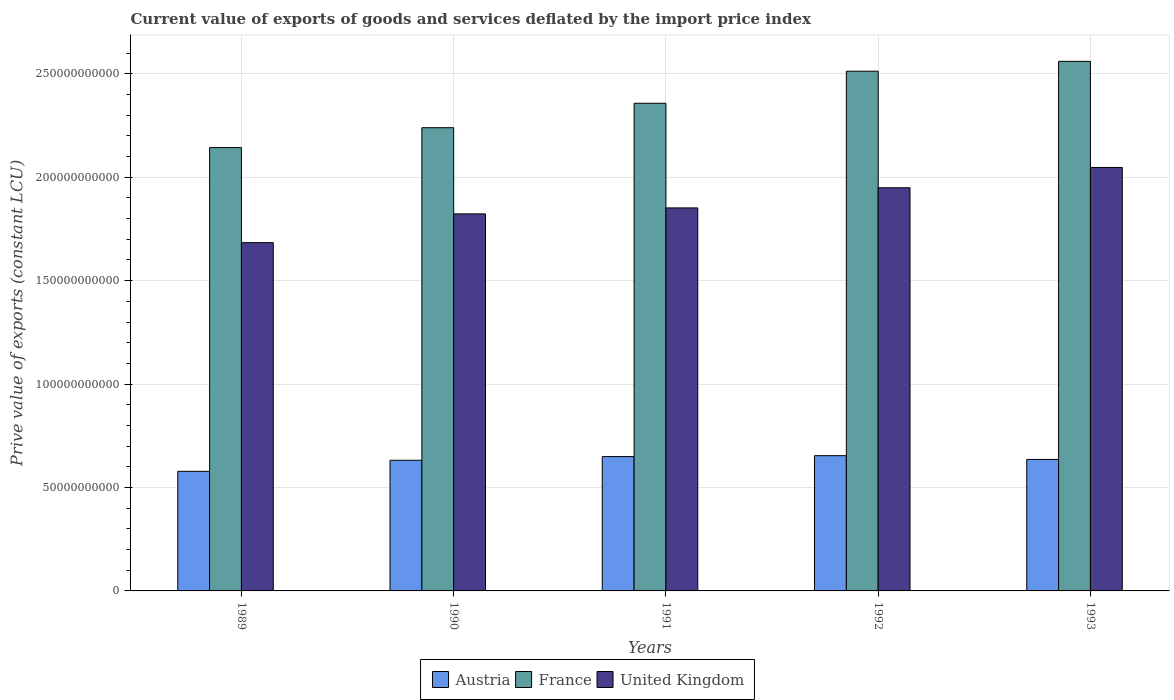How many different coloured bars are there?
Give a very brief answer. 3. How many groups of bars are there?
Your answer should be very brief. 5. Are the number of bars on each tick of the X-axis equal?
Make the answer very short. Yes. How many bars are there on the 2nd tick from the left?
Your response must be concise. 3. In how many cases, is the number of bars for a given year not equal to the number of legend labels?
Give a very brief answer. 0. What is the prive value of exports in France in 1991?
Make the answer very short. 2.36e+11. Across all years, what is the maximum prive value of exports in Austria?
Your answer should be very brief. 6.54e+1. Across all years, what is the minimum prive value of exports in Austria?
Give a very brief answer. 5.78e+1. In which year was the prive value of exports in United Kingdom maximum?
Make the answer very short. 1993. In which year was the prive value of exports in Austria minimum?
Your response must be concise. 1989. What is the total prive value of exports in France in the graph?
Your answer should be compact. 1.18e+12. What is the difference between the prive value of exports in Austria in 1990 and that in 1991?
Offer a terse response. -1.78e+09. What is the difference between the prive value of exports in Austria in 1992 and the prive value of exports in France in 1991?
Provide a short and direct response. -1.70e+11. What is the average prive value of exports in United Kingdom per year?
Ensure brevity in your answer.  1.87e+11. In the year 1991, what is the difference between the prive value of exports in Austria and prive value of exports in United Kingdom?
Make the answer very short. -1.20e+11. In how many years, is the prive value of exports in United Kingdom greater than 90000000000 LCU?
Make the answer very short. 5. What is the ratio of the prive value of exports in France in 1990 to that in 1991?
Your answer should be compact. 0.95. What is the difference between the highest and the second highest prive value of exports in Austria?
Provide a succinct answer. 4.35e+08. What is the difference between the highest and the lowest prive value of exports in United Kingdom?
Give a very brief answer. 3.63e+1. In how many years, is the prive value of exports in United Kingdom greater than the average prive value of exports in United Kingdom taken over all years?
Your response must be concise. 2. What does the 2nd bar from the right in 1993 represents?
Your answer should be compact. France. Are all the bars in the graph horizontal?
Offer a very short reply. No. Are the values on the major ticks of Y-axis written in scientific E-notation?
Your answer should be compact. No. Does the graph contain any zero values?
Give a very brief answer. No. Does the graph contain grids?
Provide a succinct answer. Yes. How many legend labels are there?
Keep it short and to the point. 3. How are the legend labels stacked?
Provide a succinct answer. Horizontal. What is the title of the graph?
Give a very brief answer. Current value of exports of goods and services deflated by the import price index. What is the label or title of the X-axis?
Your response must be concise. Years. What is the label or title of the Y-axis?
Give a very brief answer. Prive value of exports (constant LCU). What is the Prive value of exports (constant LCU) in Austria in 1989?
Your response must be concise. 5.78e+1. What is the Prive value of exports (constant LCU) in France in 1989?
Ensure brevity in your answer.  2.14e+11. What is the Prive value of exports (constant LCU) in United Kingdom in 1989?
Offer a terse response. 1.68e+11. What is the Prive value of exports (constant LCU) in Austria in 1990?
Offer a terse response. 6.32e+1. What is the Prive value of exports (constant LCU) of France in 1990?
Keep it short and to the point. 2.24e+11. What is the Prive value of exports (constant LCU) of United Kingdom in 1990?
Your response must be concise. 1.82e+11. What is the Prive value of exports (constant LCU) of Austria in 1991?
Your response must be concise. 6.49e+1. What is the Prive value of exports (constant LCU) in France in 1991?
Keep it short and to the point. 2.36e+11. What is the Prive value of exports (constant LCU) in United Kingdom in 1991?
Your answer should be very brief. 1.85e+11. What is the Prive value of exports (constant LCU) in Austria in 1992?
Your answer should be compact. 6.54e+1. What is the Prive value of exports (constant LCU) in France in 1992?
Ensure brevity in your answer.  2.51e+11. What is the Prive value of exports (constant LCU) of United Kingdom in 1992?
Provide a short and direct response. 1.95e+11. What is the Prive value of exports (constant LCU) in Austria in 1993?
Offer a very short reply. 6.36e+1. What is the Prive value of exports (constant LCU) in France in 1993?
Your answer should be very brief. 2.56e+11. What is the Prive value of exports (constant LCU) of United Kingdom in 1993?
Offer a very short reply. 2.05e+11. Across all years, what is the maximum Prive value of exports (constant LCU) of Austria?
Your response must be concise. 6.54e+1. Across all years, what is the maximum Prive value of exports (constant LCU) in France?
Give a very brief answer. 2.56e+11. Across all years, what is the maximum Prive value of exports (constant LCU) in United Kingdom?
Provide a succinct answer. 2.05e+11. Across all years, what is the minimum Prive value of exports (constant LCU) in Austria?
Your answer should be very brief. 5.78e+1. Across all years, what is the minimum Prive value of exports (constant LCU) in France?
Make the answer very short. 2.14e+11. Across all years, what is the minimum Prive value of exports (constant LCU) of United Kingdom?
Offer a terse response. 1.68e+11. What is the total Prive value of exports (constant LCU) in Austria in the graph?
Your answer should be compact. 3.15e+11. What is the total Prive value of exports (constant LCU) of France in the graph?
Ensure brevity in your answer.  1.18e+12. What is the total Prive value of exports (constant LCU) in United Kingdom in the graph?
Provide a succinct answer. 9.35e+11. What is the difference between the Prive value of exports (constant LCU) in Austria in 1989 and that in 1990?
Keep it short and to the point. -5.35e+09. What is the difference between the Prive value of exports (constant LCU) in France in 1989 and that in 1990?
Keep it short and to the point. -9.61e+09. What is the difference between the Prive value of exports (constant LCU) in United Kingdom in 1989 and that in 1990?
Offer a very short reply. -1.39e+1. What is the difference between the Prive value of exports (constant LCU) in Austria in 1989 and that in 1991?
Provide a succinct answer. -7.13e+09. What is the difference between the Prive value of exports (constant LCU) of France in 1989 and that in 1991?
Give a very brief answer. -2.14e+1. What is the difference between the Prive value of exports (constant LCU) in United Kingdom in 1989 and that in 1991?
Give a very brief answer. -1.68e+1. What is the difference between the Prive value of exports (constant LCU) of Austria in 1989 and that in 1992?
Your answer should be compact. -7.57e+09. What is the difference between the Prive value of exports (constant LCU) of France in 1989 and that in 1992?
Your answer should be very brief. -3.69e+1. What is the difference between the Prive value of exports (constant LCU) in United Kingdom in 1989 and that in 1992?
Your answer should be very brief. -2.65e+1. What is the difference between the Prive value of exports (constant LCU) in Austria in 1989 and that in 1993?
Give a very brief answer. -5.75e+09. What is the difference between the Prive value of exports (constant LCU) of France in 1989 and that in 1993?
Offer a terse response. -4.17e+1. What is the difference between the Prive value of exports (constant LCU) of United Kingdom in 1989 and that in 1993?
Make the answer very short. -3.63e+1. What is the difference between the Prive value of exports (constant LCU) in Austria in 1990 and that in 1991?
Offer a terse response. -1.78e+09. What is the difference between the Prive value of exports (constant LCU) in France in 1990 and that in 1991?
Give a very brief answer. -1.18e+1. What is the difference between the Prive value of exports (constant LCU) of United Kingdom in 1990 and that in 1991?
Give a very brief answer. -2.89e+09. What is the difference between the Prive value of exports (constant LCU) of Austria in 1990 and that in 1992?
Your answer should be very brief. -2.21e+09. What is the difference between the Prive value of exports (constant LCU) of France in 1990 and that in 1992?
Ensure brevity in your answer.  -2.73e+1. What is the difference between the Prive value of exports (constant LCU) of United Kingdom in 1990 and that in 1992?
Provide a succinct answer. -1.26e+1. What is the difference between the Prive value of exports (constant LCU) of Austria in 1990 and that in 1993?
Your response must be concise. -4.00e+08. What is the difference between the Prive value of exports (constant LCU) in France in 1990 and that in 1993?
Give a very brief answer. -3.21e+1. What is the difference between the Prive value of exports (constant LCU) of United Kingdom in 1990 and that in 1993?
Offer a very short reply. -2.24e+1. What is the difference between the Prive value of exports (constant LCU) in Austria in 1991 and that in 1992?
Your response must be concise. -4.35e+08. What is the difference between the Prive value of exports (constant LCU) in France in 1991 and that in 1992?
Ensure brevity in your answer.  -1.55e+1. What is the difference between the Prive value of exports (constant LCU) in United Kingdom in 1991 and that in 1992?
Provide a succinct answer. -9.74e+09. What is the difference between the Prive value of exports (constant LCU) in Austria in 1991 and that in 1993?
Your answer should be compact. 1.38e+09. What is the difference between the Prive value of exports (constant LCU) in France in 1991 and that in 1993?
Offer a very short reply. -2.03e+1. What is the difference between the Prive value of exports (constant LCU) in United Kingdom in 1991 and that in 1993?
Provide a short and direct response. -1.96e+1. What is the difference between the Prive value of exports (constant LCU) in Austria in 1992 and that in 1993?
Your answer should be very brief. 1.81e+09. What is the difference between the Prive value of exports (constant LCU) in France in 1992 and that in 1993?
Your response must be concise. -4.76e+09. What is the difference between the Prive value of exports (constant LCU) of United Kingdom in 1992 and that in 1993?
Provide a short and direct response. -9.81e+09. What is the difference between the Prive value of exports (constant LCU) of Austria in 1989 and the Prive value of exports (constant LCU) of France in 1990?
Give a very brief answer. -1.66e+11. What is the difference between the Prive value of exports (constant LCU) of Austria in 1989 and the Prive value of exports (constant LCU) of United Kingdom in 1990?
Make the answer very short. -1.24e+11. What is the difference between the Prive value of exports (constant LCU) in France in 1989 and the Prive value of exports (constant LCU) in United Kingdom in 1990?
Provide a short and direct response. 3.20e+1. What is the difference between the Prive value of exports (constant LCU) of Austria in 1989 and the Prive value of exports (constant LCU) of France in 1991?
Provide a succinct answer. -1.78e+11. What is the difference between the Prive value of exports (constant LCU) of Austria in 1989 and the Prive value of exports (constant LCU) of United Kingdom in 1991?
Your answer should be very brief. -1.27e+11. What is the difference between the Prive value of exports (constant LCU) of France in 1989 and the Prive value of exports (constant LCU) of United Kingdom in 1991?
Your response must be concise. 2.92e+1. What is the difference between the Prive value of exports (constant LCU) in Austria in 1989 and the Prive value of exports (constant LCU) in France in 1992?
Your answer should be compact. -1.93e+11. What is the difference between the Prive value of exports (constant LCU) in Austria in 1989 and the Prive value of exports (constant LCU) in United Kingdom in 1992?
Provide a succinct answer. -1.37e+11. What is the difference between the Prive value of exports (constant LCU) in France in 1989 and the Prive value of exports (constant LCU) in United Kingdom in 1992?
Offer a very short reply. 1.94e+1. What is the difference between the Prive value of exports (constant LCU) in Austria in 1989 and the Prive value of exports (constant LCU) in France in 1993?
Provide a succinct answer. -1.98e+11. What is the difference between the Prive value of exports (constant LCU) in Austria in 1989 and the Prive value of exports (constant LCU) in United Kingdom in 1993?
Make the answer very short. -1.47e+11. What is the difference between the Prive value of exports (constant LCU) in France in 1989 and the Prive value of exports (constant LCU) in United Kingdom in 1993?
Offer a terse response. 9.61e+09. What is the difference between the Prive value of exports (constant LCU) of Austria in 1990 and the Prive value of exports (constant LCU) of France in 1991?
Your answer should be very brief. -1.73e+11. What is the difference between the Prive value of exports (constant LCU) of Austria in 1990 and the Prive value of exports (constant LCU) of United Kingdom in 1991?
Keep it short and to the point. -1.22e+11. What is the difference between the Prive value of exports (constant LCU) of France in 1990 and the Prive value of exports (constant LCU) of United Kingdom in 1991?
Ensure brevity in your answer.  3.88e+1. What is the difference between the Prive value of exports (constant LCU) in Austria in 1990 and the Prive value of exports (constant LCU) in France in 1992?
Give a very brief answer. -1.88e+11. What is the difference between the Prive value of exports (constant LCU) of Austria in 1990 and the Prive value of exports (constant LCU) of United Kingdom in 1992?
Make the answer very short. -1.32e+11. What is the difference between the Prive value of exports (constant LCU) in France in 1990 and the Prive value of exports (constant LCU) in United Kingdom in 1992?
Ensure brevity in your answer.  2.90e+1. What is the difference between the Prive value of exports (constant LCU) of Austria in 1990 and the Prive value of exports (constant LCU) of France in 1993?
Your answer should be compact. -1.93e+11. What is the difference between the Prive value of exports (constant LCU) of Austria in 1990 and the Prive value of exports (constant LCU) of United Kingdom in 1993?
Keep it short and to the point. -1.42e+11. What is the difference between the Prive value of exports (constant LCU) in France in 1990 and the Prive value of exports (constant LCU) in United Kingdom in 1993?
Your response must be concise. 1.92e+1. What is the difference between the Prive value of exports (constant LCU) in Austria in 1991 and the Prive value of exports (constant LCU) in France in 1992?
Your response must be concise. -1.86e+11. What is the difference between the Prive value of exports (constant LCU) in Austria in 1991 and the Prive value of exports (constant LCU) in United Kingdom in 1992?
Offer a terse response. -1.30e+11. What is the difference between the Prive value of exports (constant LCU) in France in 1991 and the Prive value of exports (constant LCU) in United Kingdom in 1992?
Offer a very short reply. 4.09e+1. What is the difference between the Prive value of exports (constant LCU) of Austria in 1991 and the Prive value of exports (constant LCU) of France in 1993?
Ensure brevity in your answer.  -1.91e+11. What is the difference between the Prive value of exports (constant LCU) in Austria in 1991 and the Prive value of exports (constant LCU) in United Kingdom in 1993?
Your answer should be very brief. -1.40e+11. What is the difference between the Prive value of exports (constant LCU) of France in 1991 and the Prive value of exports (constant LCU) of United Kingdom in 1993?
Ensure brevity in your answer.  3.10e+1. What is the difference between the Prive value of exports (constant LCU) of Austria in 1992 and the Prive value of exports (constant LCU) of France in 1993?
Offer a terse response. -1.91e+11. What is the difference between the Prive value of exports (constant LCU) of Austria in 1992 and the Prive value of exports (constant LCU) of United Kingdom in 1993?
Your answer should be very brief. -1.39e+11. What is the difference between the Prive value of exports (constant LCU) of France in 1992 and the Prive value of exports (constant LCU) of United Kingdom in 1993?
Provide a short and direct response. 4.65e+1. What is the average Prive value of exports (constant LCU) in Austria per year?
Keep it short and to the point. 6.30e+1. What is the average Prive value of exports (constant LCU) of France per year?
Keep it short and to the point. 2.36e+11. What is the average Prive value of exports (constant LCU) in United Kingdom per year?
Offer a very short reply. 1.87e+11. In the year 1989, what is the difference between the Prive value of exports (constant LCU) in Austria and Prive value of exports (constant LCU) in France?
Your answer should be compact. -1.57e+11. In the year 1989, what is the difference between the Prive value of exports (constant LCU) in Austria and Prive value of exports (constant LCU) in United Kingdom?
Provide a short and direct response. -1.11e+11. In the year 1989, what is the difference between the Prive value of exports (constant LCU) of France and Prive value of exports (constant LCU) of United Kingdom?
Give a very brief answer. 4.60e+1. In the year 1990, what is the difference between the Prive value of exports (constant LCU) in Austria and Prive value of exports (constant LCU) in France?
Give a very brief answer. -1.61e+11. In the year 1990, what is the difference between the Prive value of exports (constant LCU) in Austria and Prive value of exports (constant LCU) in United Kingdom?
Keep it short and to the point. -1.19e+11. In the year 1990, what is the difference between the Prive value of exports (constant LCU) of France and Prive value of exports (constant LCU) of United Kingdom?
Provide a short and direct response. 4.17e+1. In the year 1991, what is the difference between the Prive value of exports (constant LCU) of Austria and Prive value of exports (constant LCU) of France?
Make the answer very short. -1.71e+11. In the year 1991, what is the difference between the Prive value of exports (constant LCU) in Austria and Prive value of exports (constant LCU) in United Kingdom?
Your response must be concise. -1.20e+11. In the year 1991, what is the difference between the Prive value of exports (constant LCU) of France and Prive value of exports (constant LCU) of United Kingdom?
Ensure brevity in your answer.  5.06e+1. In the year 1992, what is the difference between the Prive value of exports (constant LCU) of Austria and Prive value of exports (constant LCU) of France?
Your answer should be compact. -1.86e+11. In the year 1992, what is the difference between the Prive value of exports (constant LCU) of Austria and Prive value of exports (constant LCU) of United Kingdom?
Give a very brief answer. -1.30e+11. In the year 1992, what is the difference between the Prive value of exports (constant LCU) in France and Prive value of exports (constant LCU) in United Kingdom?
Keep it short and to the point. 5.63e+1. In the year 1993, what is the difference between the Prive value of exports (constant LCU) in Austria and Prive value of exports (constant LCU) in France?
Offer a very short reply. -1.92e+11. In the year 1993, what is the difference between the Prive value of exports (constant LCU) in Austria and Prive value of exports (constant LCU) in United Kingdom?
Your response must be concise. -1.41e+11. In the year 1993, what is the difference between the Prive value of exports (constant LCU) of France and Prive value of exports (constant LCU) of United Kingdom?
Provide a short and direct response. 5.13e+1. What is the ratio of the Prive value of exports (constant LCU) in Austria in 1989 to that in 1990?
Your answer should be compact. 0.92. What is the ratio of the Prive value of exports (constant LCU) of France in 1989 to that in 1990?
Your response must be concise. 0.96. What is the ratio of the Prive value of exports (constant LCU) of United Kingdom in 1989 to that in 1990?
Your answer should be very brief. 0.92. What is the ratio of the Prive value of exports (constant LCU) in Austria in 1989 to that in 1991?
Give a very brief answer. 0.89. What is the ratio of the Prive value of exports (constant LCU) of France in 1989 to that in 1991?
Provide a short and direct response. 0.91. What is the ratio of the Prive value of exports (constant LCU) of United Kingdom in 1989 to that in 1991?
Provide a short and direct response. 0.91. What is the ratio of the Prive value of exports (constant LCU) of Austria in 1989 to that in 1992?
Your response must be concise. 0.88. What is the ratio of the Prive value of exports (constant LCU) in France in 1989 to that in 1992?
Your answer should be very brief. 0.85. What is the ratio of the Prive value of exports (constant LCU) of United Kingdom in 1989 to that in 1992?
Your answer should be very brief. 0.86. What is the ratio of the Prive value of exports (constant LCU) in Austria in 1989 to that in 1993?
Your answer should be very brief. 0.91. What is the ratio of the Prive value of exports (constant LCU) of France in 1989 to that in 1993?
Provide a succinct answer. 0.84. What is the ratio of the Prive value of exports (constant LCU) of United Kingdom in 1989 to that in 1993?
Ensure brevity in your answer.  0.82. What is the ratio of the Prive value of exports (constant LCU) in Austria in 1990 to that in 1991?
Your answer should be compact. 0.97. What is the ratio of the Prive value of exports (constant LCU) in France in 1990 to that in 1991?
Provide a short and direct response. 0.95. What is the ratio of the Prive value of exports (constant LCU) in United Kingdom in 1990 to that in 1991?
Your answer should be very brief. 0.98. What is the ratio of the Prive value of exports (constant LCU) in Austria in 1990 to that in 1992?
Provide a short and direct response. 0.97. What is the ratio of the Prive value of exports (constant LCU) in France in 1990 to that in 1992?
Your answer should be compact. 0.89. What is the ratio of the Prive value of exports (constant LCU) of United Kingdom in 1990 to that in 1992?
Your response must be concise. 0.94. What is the ratio of the Prive value of exports (constant LCU) in France in 1990 to that in 1993?
Your answer should be very brief. 0.87. What is the ratio of the Prive value of exports (constant LCU) of United Kingdom in 1990 to that in 1993?
Provide a short and direct response. 0.89. What is the ratio of the Prive value of exports (constant LCU) of France in 1991 to that in 1992?
Provide a succinct answer. 0.94. What is the ratio of the Prive value of exports (constant LCU) in United Kingdom in 1991 to that in 1992?
Your answer should be compact. 0.95. What is the ratio of the Prive value of exports (constant LCU) of Austria in 1991 to that in 1993?
Offer a terse response. 1.02. What is the ratio of the Prive value of exports (constant LCU) in France in 1991 to that in 1993?
Your response must be concise. 0.92. What is the ratio of the Prive value of exports (constant LCU) of United Kingdom in 1991 to that in 1993?
Give a very brief answer. 0.9. What is the ratio of the Prive value of exports (constant LCU) of Austria in 1992 to that in 1993?
Your answer should be compact. 1.03. What is the ratio of the Prive value of exports (constant LCU) of France in 1992 to that in 1993?
Offer a terse response. 0.98. What is the ratio of the Prive value of exports (constant LCU) of United Kingdom in 1992 to that in 1993?
Offer a terse response. 0.95. What is the difference between the highest and the second highest Prive value of exports (constant LCU) of Austria?
Give a very brief answer. 4.35e+08. What is the difference between the highest and the second highest Prive value of exports (constant LCU) of France?
Ensure brevity in your answer.  4.76e+09. What is the difference between the highest and the second highest Prive value of exports (constant LCU) in United Kingdom?
Give a very brief answer. 9.81e+09. What is the difference between the highest and the lowest Prive value of exports (constant LCU) of Austria?
Give a very brief answer. 7.57e+09. What is the difference between the highest and the lowest Prive value of exports (constant LCU) of France?
Your response must be concise. 4.17e+1. What is the difference between the highest and the lowest Prive value of exports (constant LCU) of United Kingdom?
Give a very brief answer. 3.63e+1. 